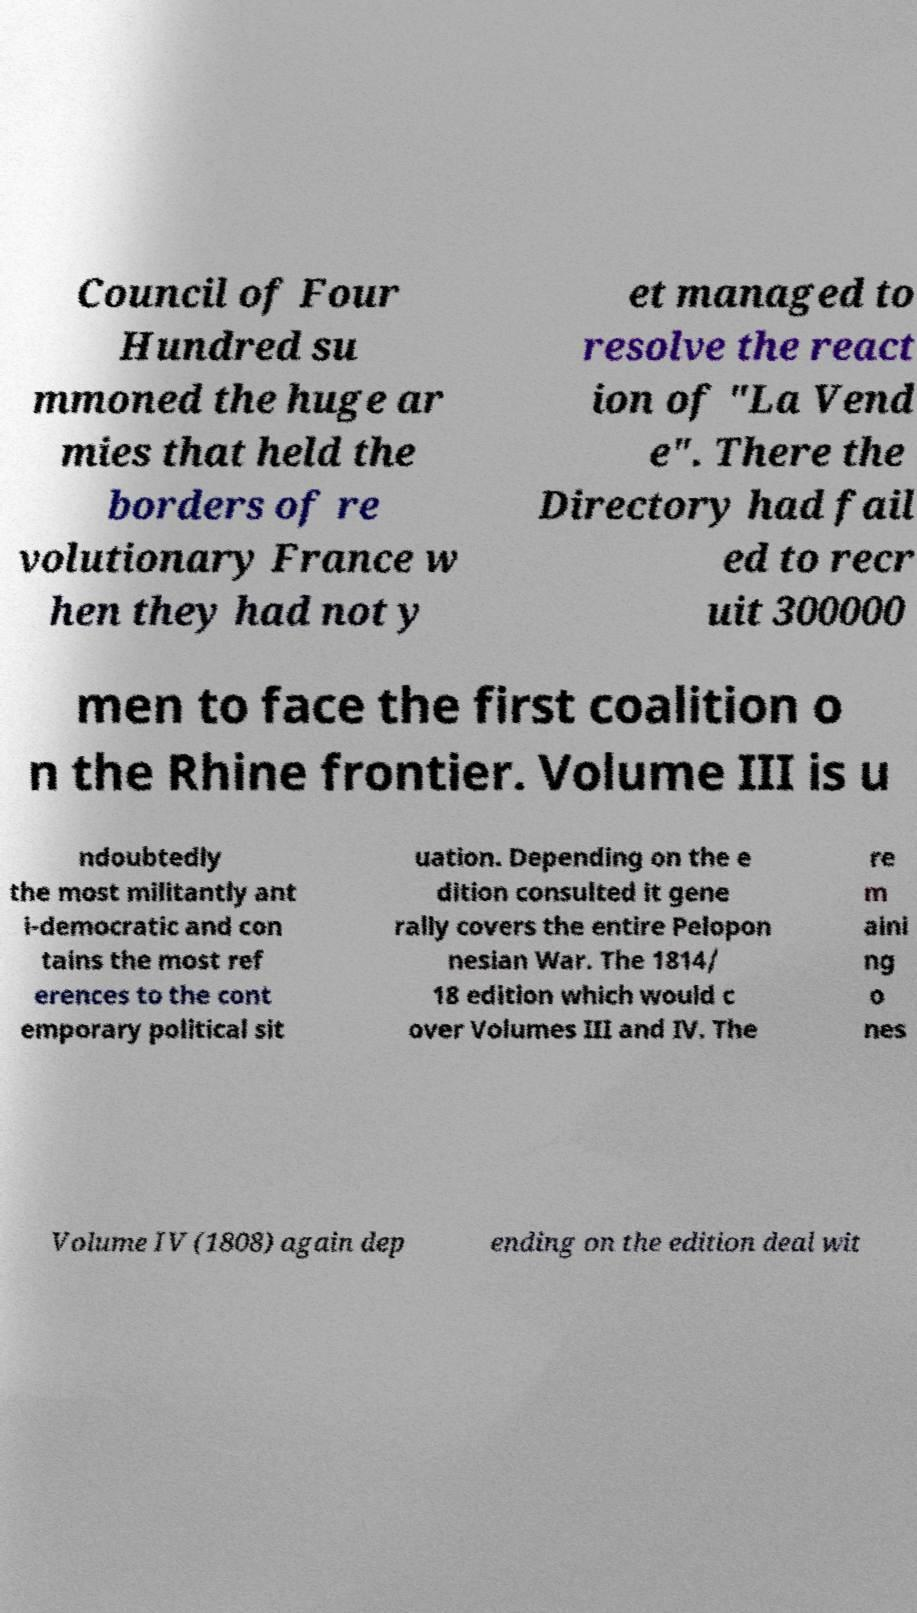Please identify and transcribe the text found in this image. Council of Four Hundred su mmoned the huge ar mies that held the borders of re volutionary France w hen they had not y et managed to resolve the react ion of "La Vend e". There the Directory had fail ed to recr uit 300000 men to face the first coalition o n the Rhine frontier. Volume III is u ndoubtedly the most militantly ant i-democratic and con tains the most ref erences to the cont emporary political sit uation. Depending on the e dition consulted it gene rally covers the entire Pelopon nesian War. The 1814/ 18 edition which would c over Volumes III and IV. The re m aini ng o nes Volume IV (1808) again dep ending on the edition deal wit 